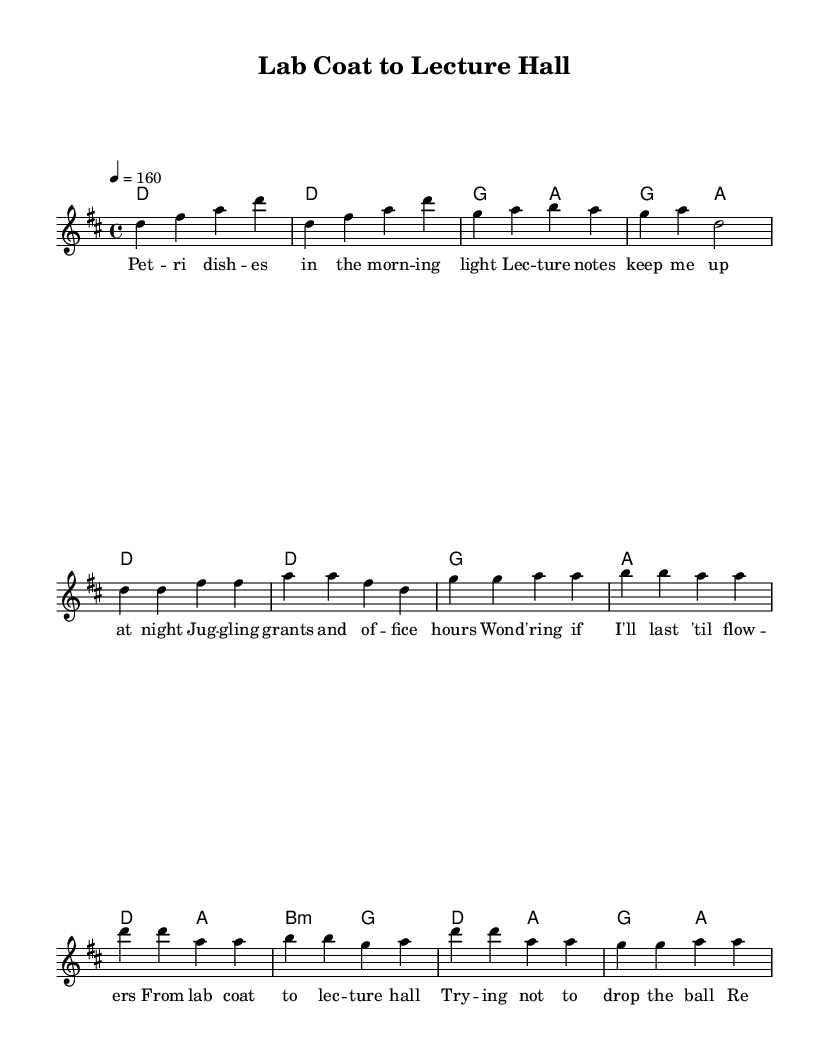What is the key signature of this music? The key signature is indicated by the sharp signs and the reference to related scales. In this case, D major has two sharps (F# and C#), evident in the music sheet.
Answer: D major What is the time signature of this music? The time signature appears at the beginning of the piece, showing how many beats are in each measure. Here, it is indicated as 4/4, meaning there are four quarter note beats per measure.
Answer: 4/4 What is the tempo of this music? The tempo is indicated at the beginning of the score with a number. The piece states "4 = 160", meaning that a quarter note equals 160 beats per minute.
Answer: 160 Which section follows the verse in the structure? By examining the lyrics and structure of the music, the next section after the verse is typically the chorus. This can be inferred from the labeled lyrics sections.
Answer: Chorus How many measures are in the introduction? Counting the measures presented in the 'Intro' section indicates that there are four measures before the verse begins. Each distinct grouping of notes separated by the bar lines counts as one measure.
Answer: 4 What common theme is present in the chorus lyrics? The chorus lyrics speak to the struggles of managing different aspects of professional life. Words like "trying not to drop the ball" reflect a sense of balance that is central to Pop-punk themes.
Answer: Balancing responsibilities 